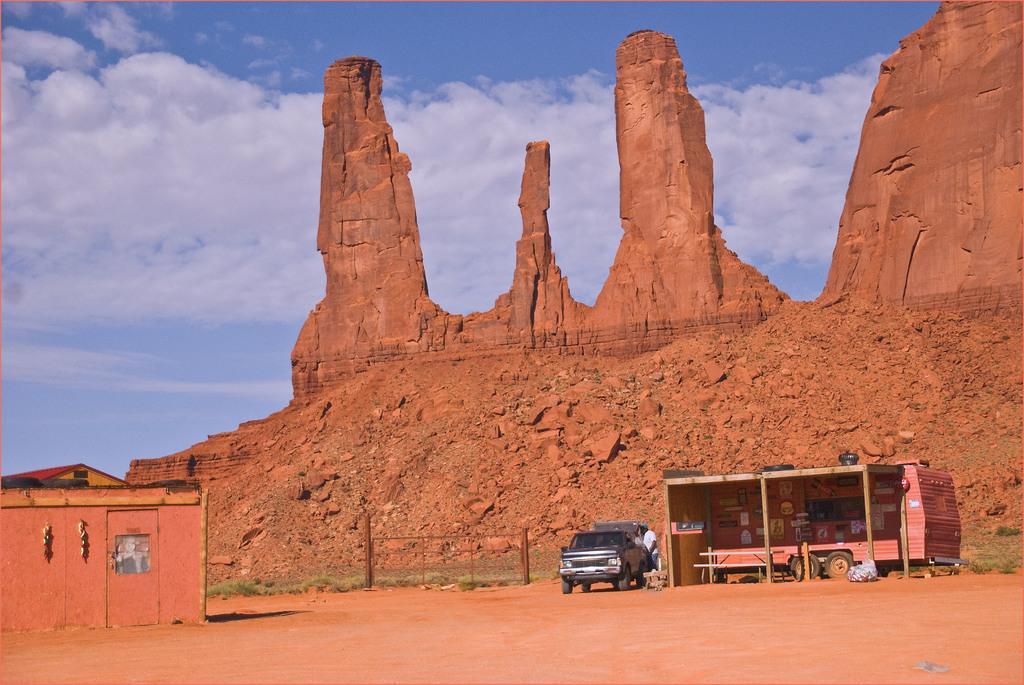Can you describe this image briefly? In this image there are vehicles. There is a wooden shed. On the left side of the image there is a house. There is a metal fence. In the background of the image there are rock structures and there is sky. 